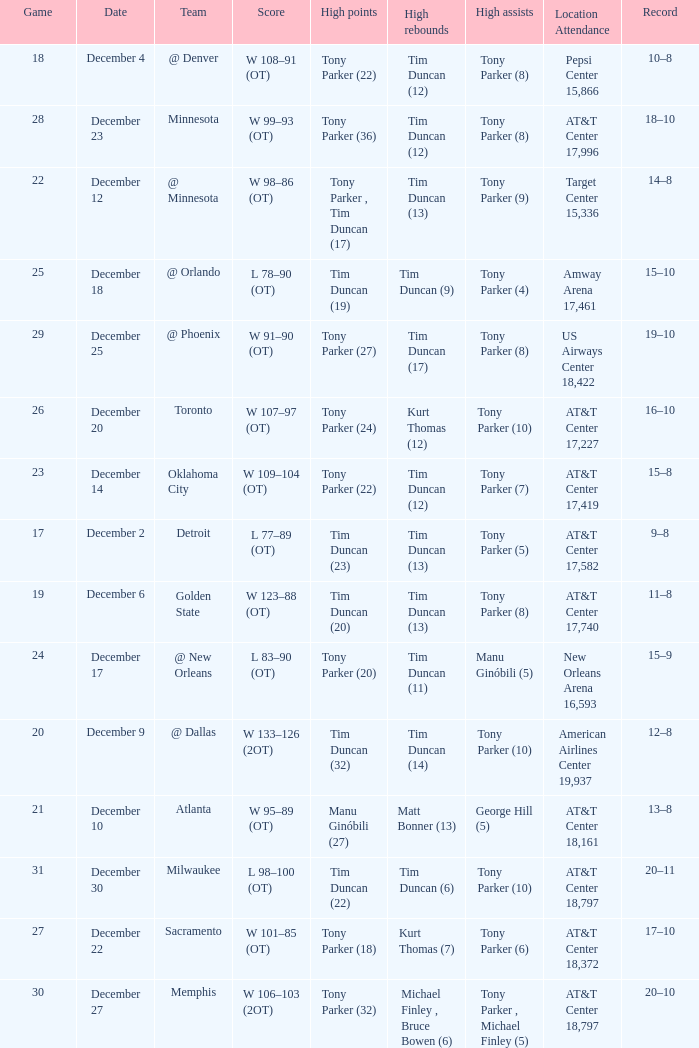What score has tim duncan (14) as the high rebounds? W 133–126 (2OT). 